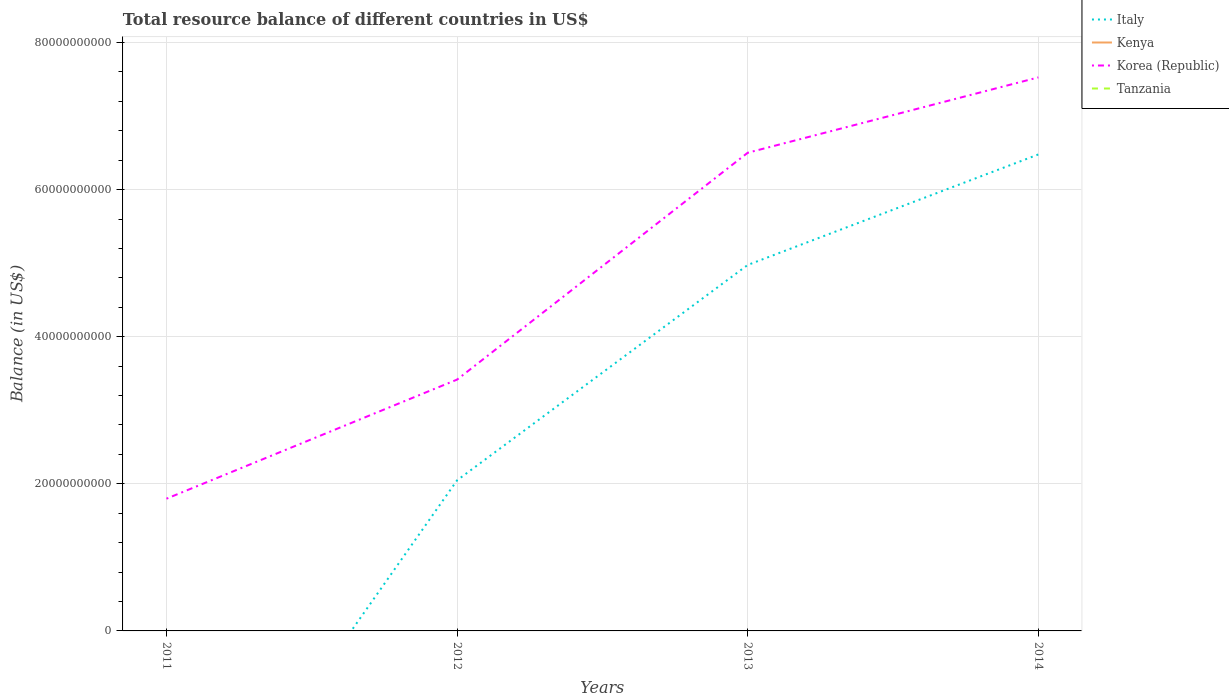How many different coloured lines are there?
Make the answer very short. 2. Is the number of lines equal to the number of legend labels?
Provide a succinct answer. No. What is the total total resource balance in Italy in the graph?
Your response must be concise. -2.93e+1. What is the difference between the highest and the second highest total resource balance in Korea (Republic)?
Give a very brief answer. 5.73e+1. Is the total resource balance in Italy strictly greater than the total resource balance in Korea (Republic) over the years?
Make the answer very short. Yes. How many lines are there?
Offer a very short reply. 2. What is the difference between two consecutive major ticks on the Y-axis?
Give a very brief answer. 2.00e+1. Where does the legend appear in the graph?
Make the answer very short. Top right. How many legend labels are there?
Give a very brief answer. 4. How are the legend labels stacked?
Offer a very short reply. Vertical. What is the title of the graph?
Offer a terse response. Total resource balance of different countries in US$. Does "Cambodia" appear as one of the legend labels in the graph?
Keep it short and to the point. No. What is the label or title of the Y-axis?
Keep it short and to the point. Balance (in US$). What is the Balance (in US$) of Italy in 2011?
Ensure brevity in your answer.  0. What is the Balance (in US$) in Korea (Republic) in 2011?
Your answer should be very brief. 1.80e+1. What is the Balance (in US$) in Italy in 2012?
Keep it short and to the point. 2.05e+1. What is the Balance (in US$) in Korea (Republic) in 2012?
Offer a terse response. 3.42e+1. What is the Balance (in US$) in Tanzania in 2012?
Offer a very short reply. 0. What is the Balance (in US$) of Italy in 2013?
Give a very brief answer. 4.98e+1. What is the Balance (in US$) of Korea (Republic) in 2013?
Make the answer very short. 6.50e+1. What is the Balance (in US$) of Tanzania in 2013?
Your answer should be compact. 0. What is the Balance (in US$) of Italy in 2014?
Make the answer very short. 6.48e+1. What is the Balance (in US$) of Korea (Republic) in 2014?
Give a very brief answer. 7.53e+1. What is the Balance (in US$) in Tanzania in 2014?
Provide a short and direct response. 0. Across all years, what is the maximum Balance (in US$) of Italy?
Provide a short and direct response. 6.48e+1. Across all years, what is the maximum Balance (in US$) of Korea (Republic)?
Offer a terse response. 7.53e+1. Across all years, what is the minimum Balance (in US$) in Korea (Republic)?
Your answer should be compact. 1.80e+1. What is the total Balance (in US$) in Italy in the graph?
Your response must be concise. 1.35e+11. What is the total Balance (in US$) in Korea (Republic) in the graph?
Give a very brief answer. 1.92e+11. What is the total Balance (in US$) in Tanzania in the graph?
Give a very brief answer. 0. What is the difference between the Balance (in US$) in Korea (Republic) in 2011 and that in 2012?
Your answer should be compact. -1.62e+1. What is the difference between the Balance (in US$) in Korea (Republic) in 2011 and that in 2013?
Provide a short and direct response. -4.70e+1. What is the difference between the Balance (in US$) in Korea (Republic) in 2011 and that in 2014?
Your answer should be very brief. -5.73e+1. What is the difference between the Balance (in US$) in Italy in 2012 and that in 2013?
Offer a very short reply. -2.93e+1. What is the difference between the Balance (in US$) of Korea (Republic) in 2012 and that in 2013?
Your response must be concise. -3.08e+1. What is the difference between the Balance (in US$) in Italy in 2012 and that in 2014?
Provide a succinct answer. -4.43e+1. What is the difference between the Balance (in US$) in Korea (Republic) in 2012 and that in 2014?
Your answer should be very brief. -4.11e+1. What is the difference between the Balance (in US$) of Italy in 2013 and that in 2014?
Offer a terse response. -1.50e+1. What is the difference between the Balance (in US$) in Korea (Republic) in 2013 and that in 2014?
Give a very brief answer. -1.02e+1. What is the difference between the Balance (in US$) of Italy in 2012 and the Balance (in US$) of Korea (Republic) in 2013?
Provide a short and direct response. -4.45e+1. What is the difference between the Balance (in US$) in Italy in 2012 and the Balance (in US$) in Korea (Republic) in 2014?
Make the answer very short. -5.48e+1. What is the difference between the Balance (in US$) in Italy in 2013 and the Balance (in US$) in Korea (Republic) in 2014?
Make the answer very short. -2.55e+1. What is the average Balance (in US$) in Italy per year?
Keep it short and to the point. 3.38e+1. What is the average Balance (in US$) in Kenya per year?
Make the answer very short. 0. What is the average Balance (in US$) in Korea (Republic) per year?
Provide a short and direct response. 4.81e+1. What is the average Balance (in US$) of Tanzania per year?
Your response must be concise. 0. In the year 2012, what is the difference between the Balance (in US$) in Italy and Balance (in US$) in Korea (Republic)?
Offer a very short reply. -1.37e+1. In the year 2013, what is the difference between the Balance (in US$) in Italy and Balance (in US$) in Korea (Republic)?
Offer a terse response. -1.53e+1. In the year 2014, what is the difference between the Balance (in US$) in Italy and Balance (in US$) in Korea (Republic)?
Keep it short and to the point. -1.05e+1. What is the ratio of the Balance (in US$) in Korea (Republic) in 2011 to that in 2012?
Provide a succinct answer. 0.53. What is the ratio of the Balance (in US$) of Korea (Republic) in 2011 to that in 2013?
Your answer should be very brief. 0.28. What is the ratio of the Balance (in US$) of Korea (Republic) in 2011 to that in 2014?
Keep it short and to the point. 0.24. What is the ratio of the Balance (in US$) of Italy in 2012 to that in 2013?
Offer a terse response. 0.41. What is the ratio of the Balance (in US$) of Korea (Republic) in 2012 to that in 2013?
Your answer should be compact. 0.53. What is the ratio of the Balance (in US$) of Italy in 2012 to that in 2014?
Make the answer very short. 0.32. What is the ratio of the Balance (in US$) of Korea (Republic) in 2012 to that in 2014?
Your answer should be very brief. 0.45. What is the ratio of the Balance (in US$) in Italy in 2013 to that in 2014?
Provide a succinct answer. 0.77. What is the ratio of the Balance (in US$) in Korea (Republic) in 2013 to that in 2014?
Give a very brief answer. 0.86. What is the difference between the highest and the second highest Balance (in US$) in Italy?
Offer a very short reply. 1.50e+1. What is the difference between the highest and the second highest Balance (in US$) of Korea (Republic)?
Make the answer very short. 1.02e+1. What is the difference between the highest and the lowest Balance (in US$) of Italy?
Keep it short and to the point. 6.48e+1. What is the difference between the highest and the lowest Balance (in US$) of Korea (Republic)?
Offer a very short reply. 5.73e+1. 